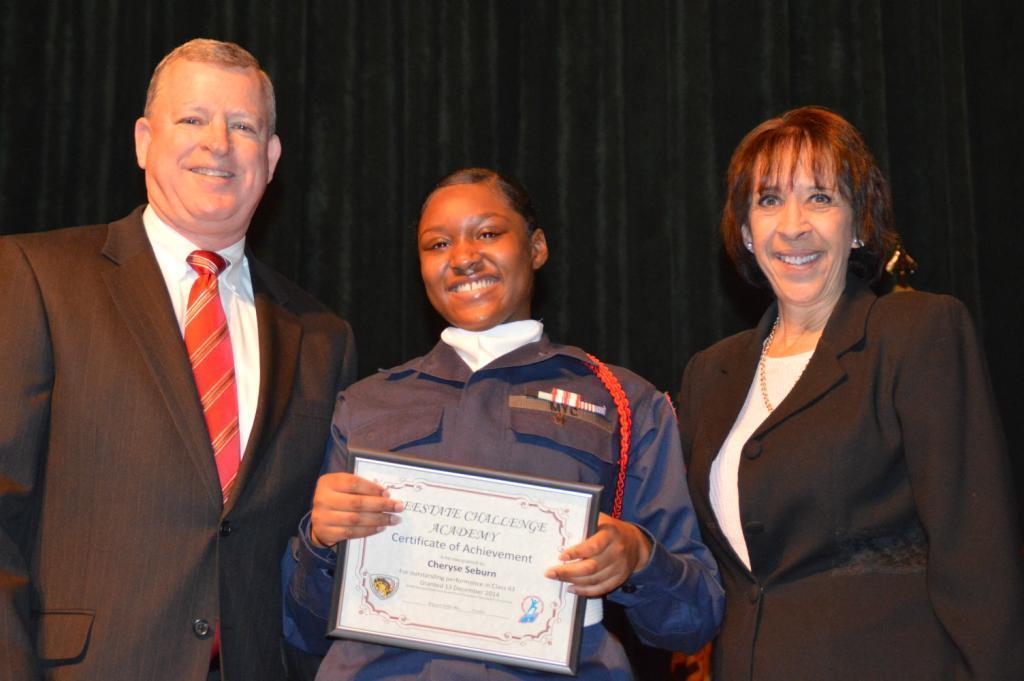In one or two sentences, can you explain what this image depicts? In this image I can see three people with different color dresses. I can see one person holding the board and I can see the black background. 